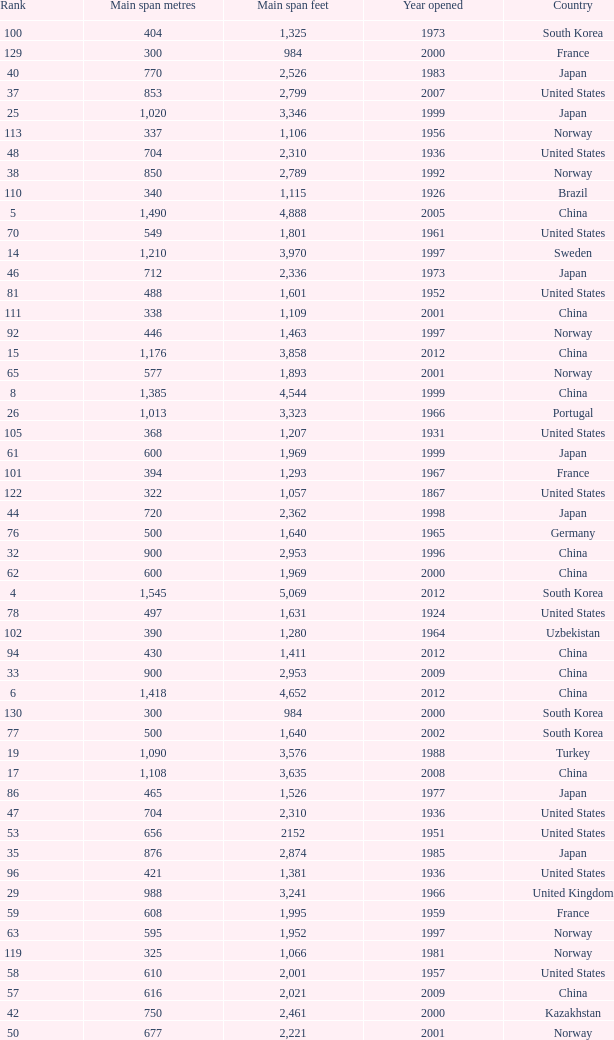What is the highest rank from the year greater than 2010 with 430 main span metres? 94.0. 